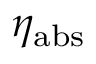<formula> <loc_0><loc_0><loc_500><loc_500>\eta _ { a b s }</formula> 